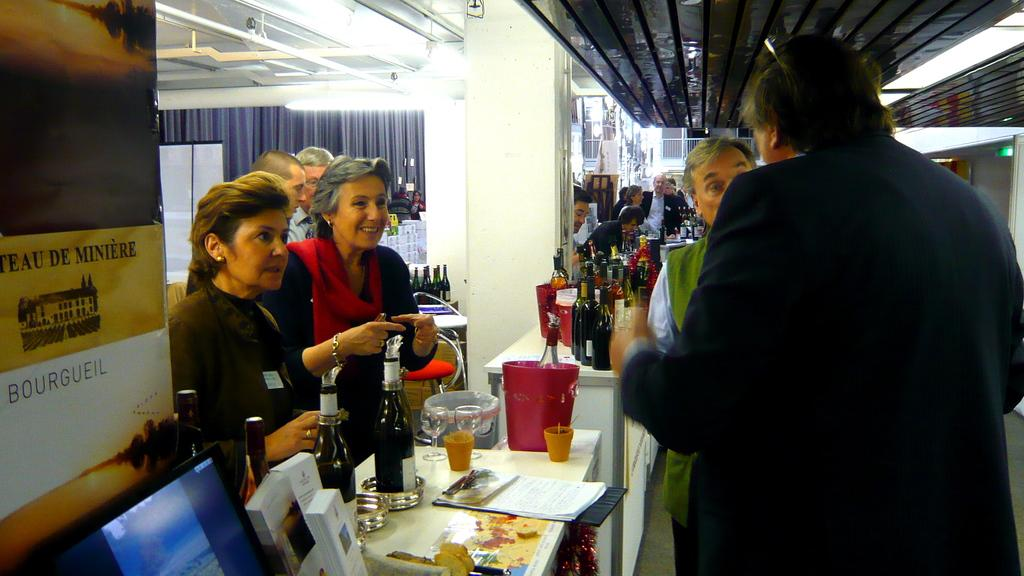What type of furniture is present in the image? There are tables in the image. What items are related to drinking in the image? There are alcohol bottles and glasses in the image. What are the people near the tables doing? People are standing near the tables. What type of window treatment is visible in the image? There is a curtain on the backside of the image. What type of lighting is present in the image? There are lights on the top of the image. Can you describe the action taking place in the sea in the image? There is no sea present in the image; it features tables, alcohol bottles, glasses, people, a curtain, and lights. What type of advertisement is displayed on the curtain in the image? There is no advertisement displayed on the curtain in the image; it is simply a window treatment. 